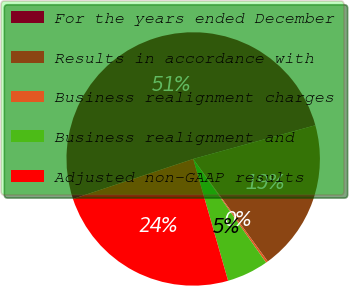Convert chart to OTSL. <chart><loc_0><loc_0><loc_500><loc_500><pie_chart><fcel>For the years ended December<fcel>Results in accordance with<fcel>Business realignment charges<fcel>Business realignment and<fcel>Adjusted non-GAAP results<nl><fcel>50.83%<fcel>19.27%<fcel>0.26%<fcel>5.31%<fcel>24.33%<nl></chart> 